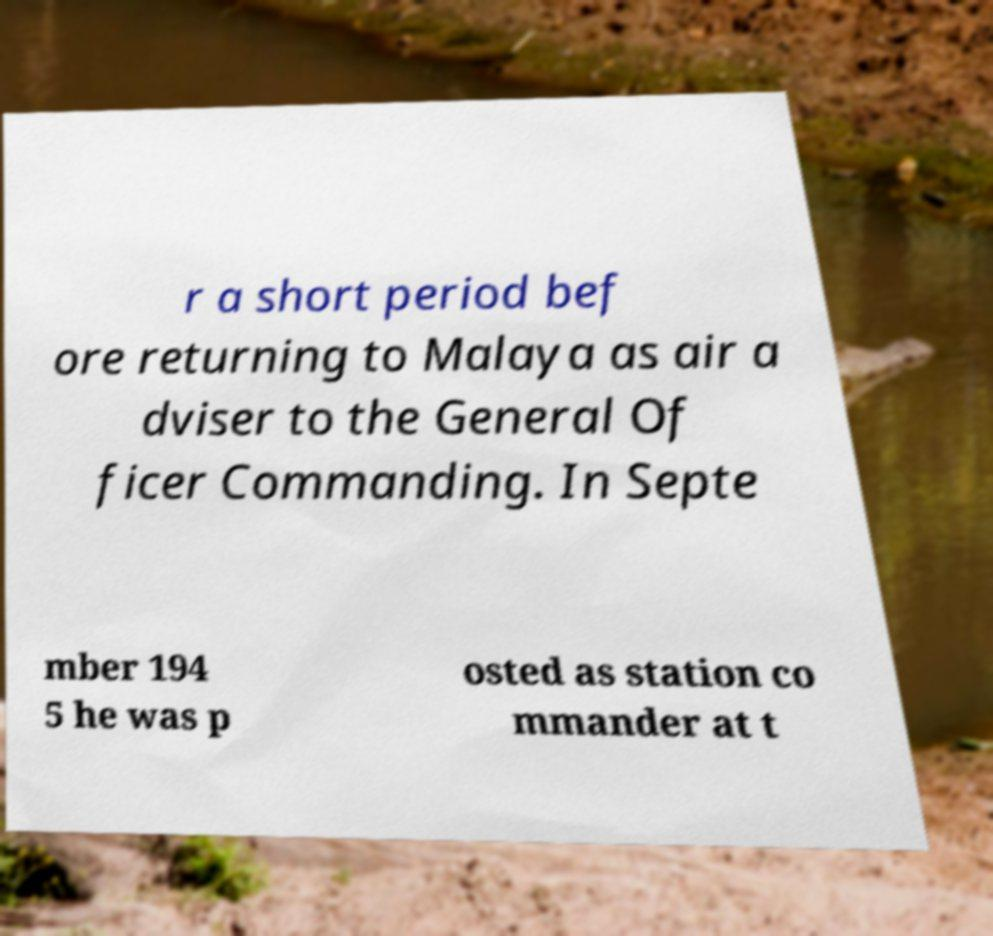Could you extract and type out the text from this image? r a short period bef ore returning to Malaya as air a dviser to the General Of ficer Commanding. In Septe mber 194 5 he was p osted as station co mmander at t 